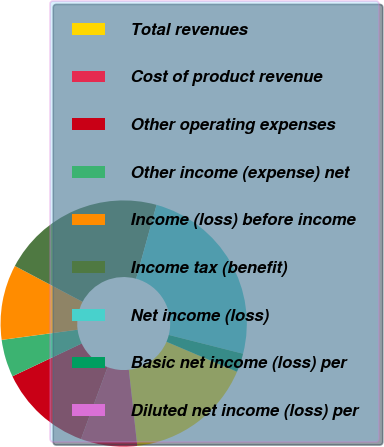Convert chart to OTSL. <chart><loc_0><loc_0><loc_500><loc_500><pie_chart><fcel>Total revenues<fcel>Cost of product revenue<fcel>Other operating expenses<fcel>Other income (expense) net<fcel>Income (loss) before income<fcel>Income tax (benefit)<fcel>Net income (loss)<fcel>Basic net income (loss) per<fcel>Diluted net income (loss) per<nl><fcel>16.84%<fcel>7.39%<fcel>12.32%<fcel>4.93%<fcel>9.86%<fcel>21.56%<fcel>24.64%<fcel>2.46%<fcel>0.0%<nl></chart> 